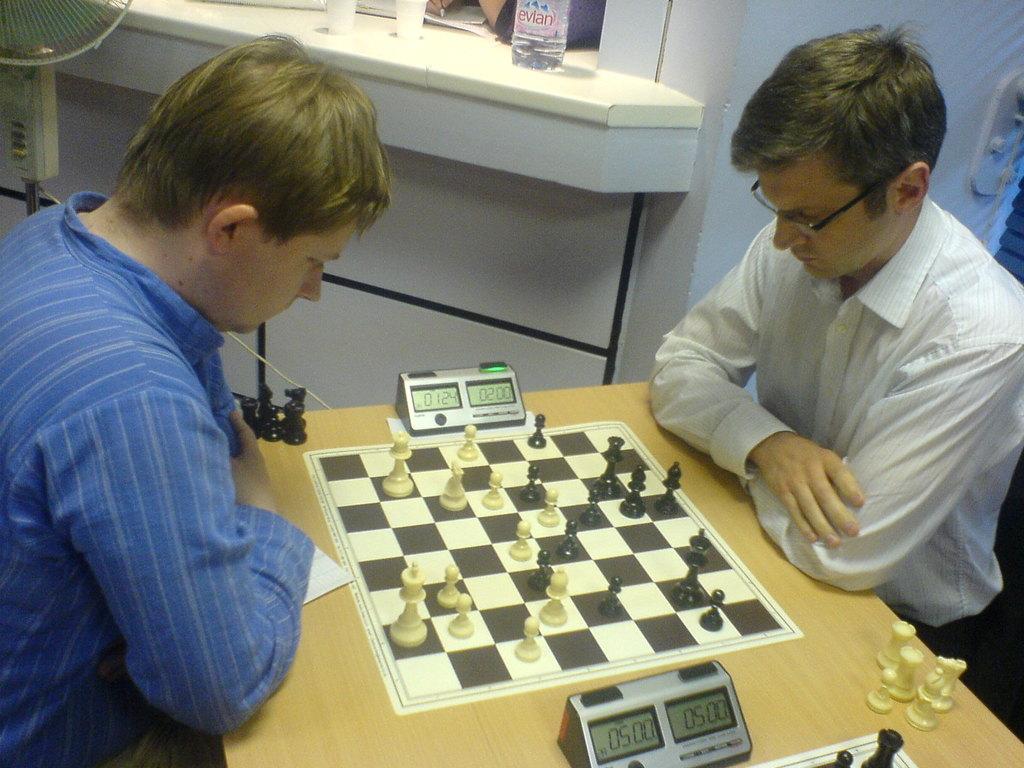Can you describe this image briefly? This image is clicked in a room where there is a table in the middle ,on the table there is a timer and chess board, chess coins. There are two people sitting near the table ,they are playing chess. The one who is on the left side is wearing black ,blue shirt the one who is on the right side is wearing white shirt. There is a water bottle on the top and the table fan on the top left corner. 